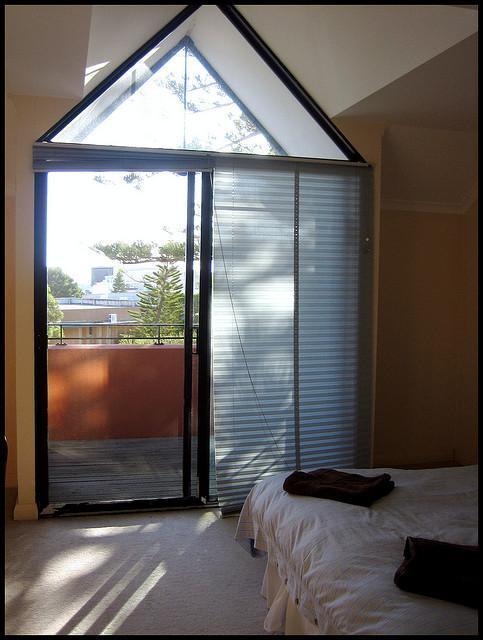How many trees are on the left side?
Give a very brief answer. 2. How many light color cars are there?
Give a very brief answer. 0. 